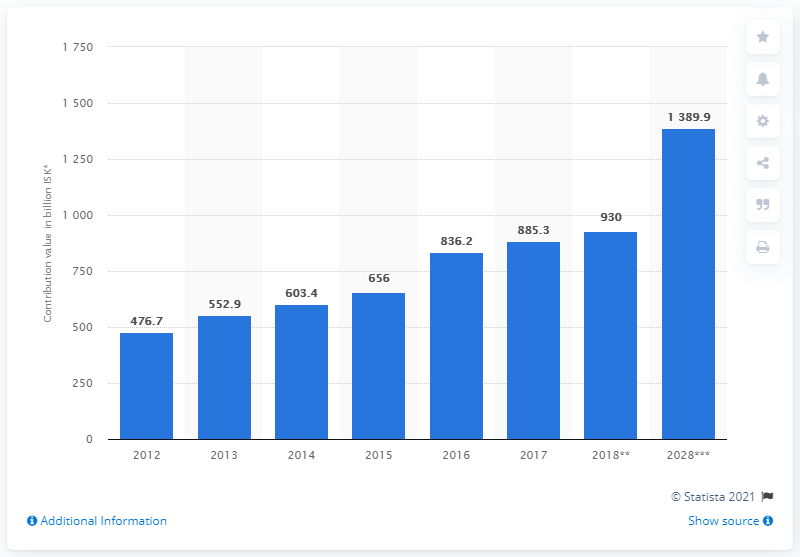Identify some key points in this picture. In 2017, the travel and tourism industry contributed 885.3% to Iceland's Gross Domestic Product (GDP). 